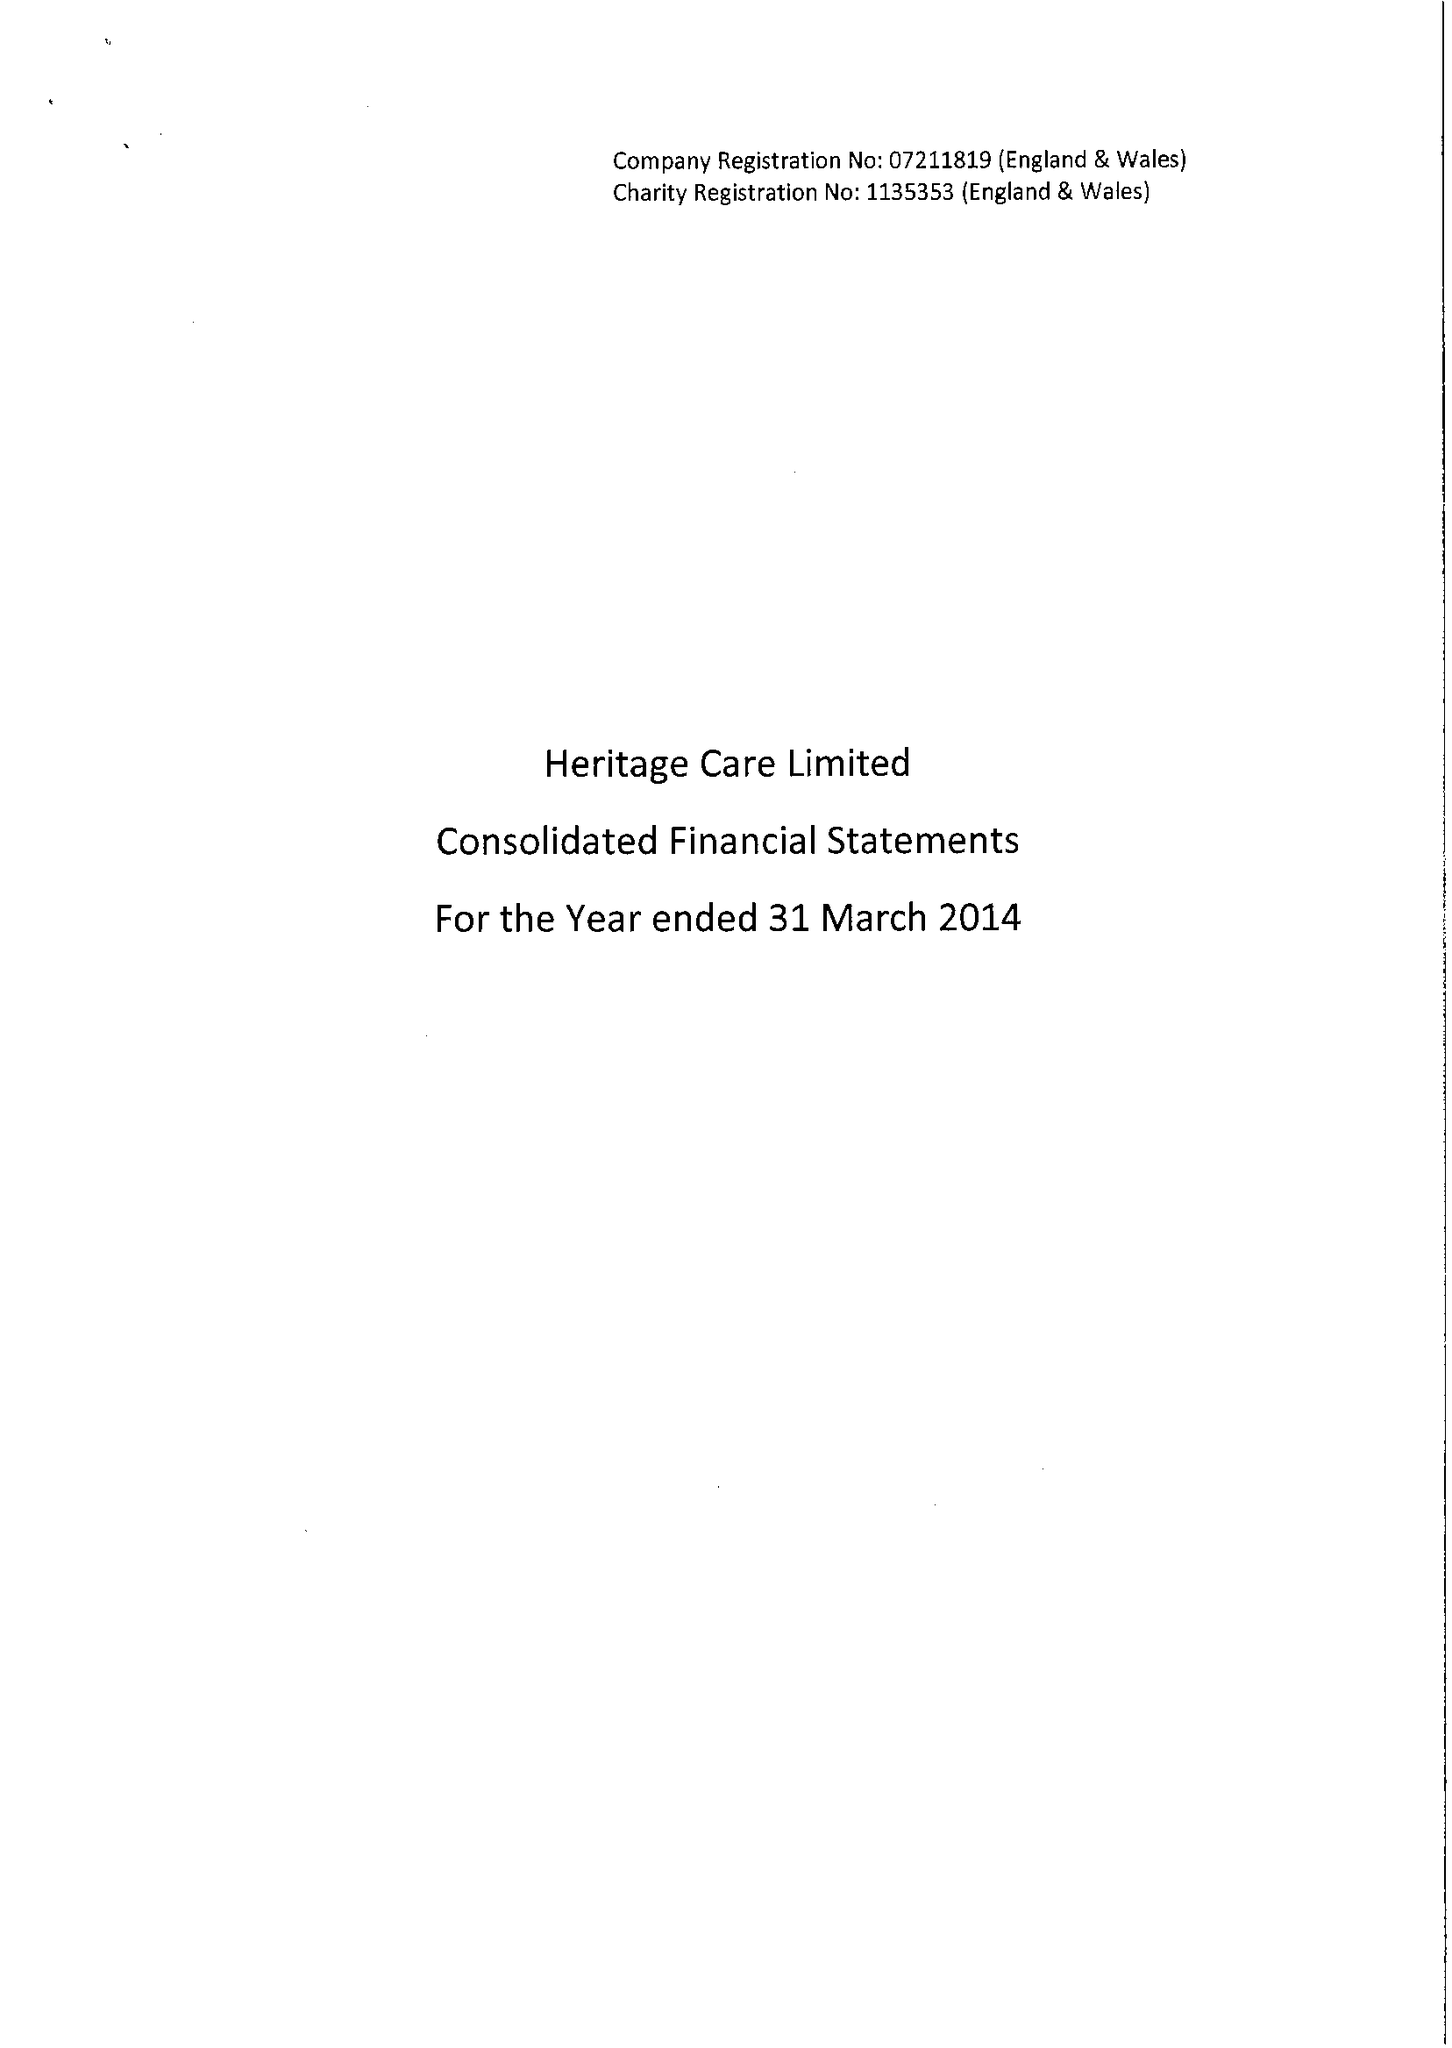What is the value for the address__street_line?
Answer the question using a single word or phrase. 112-120 HIGH ROAD 